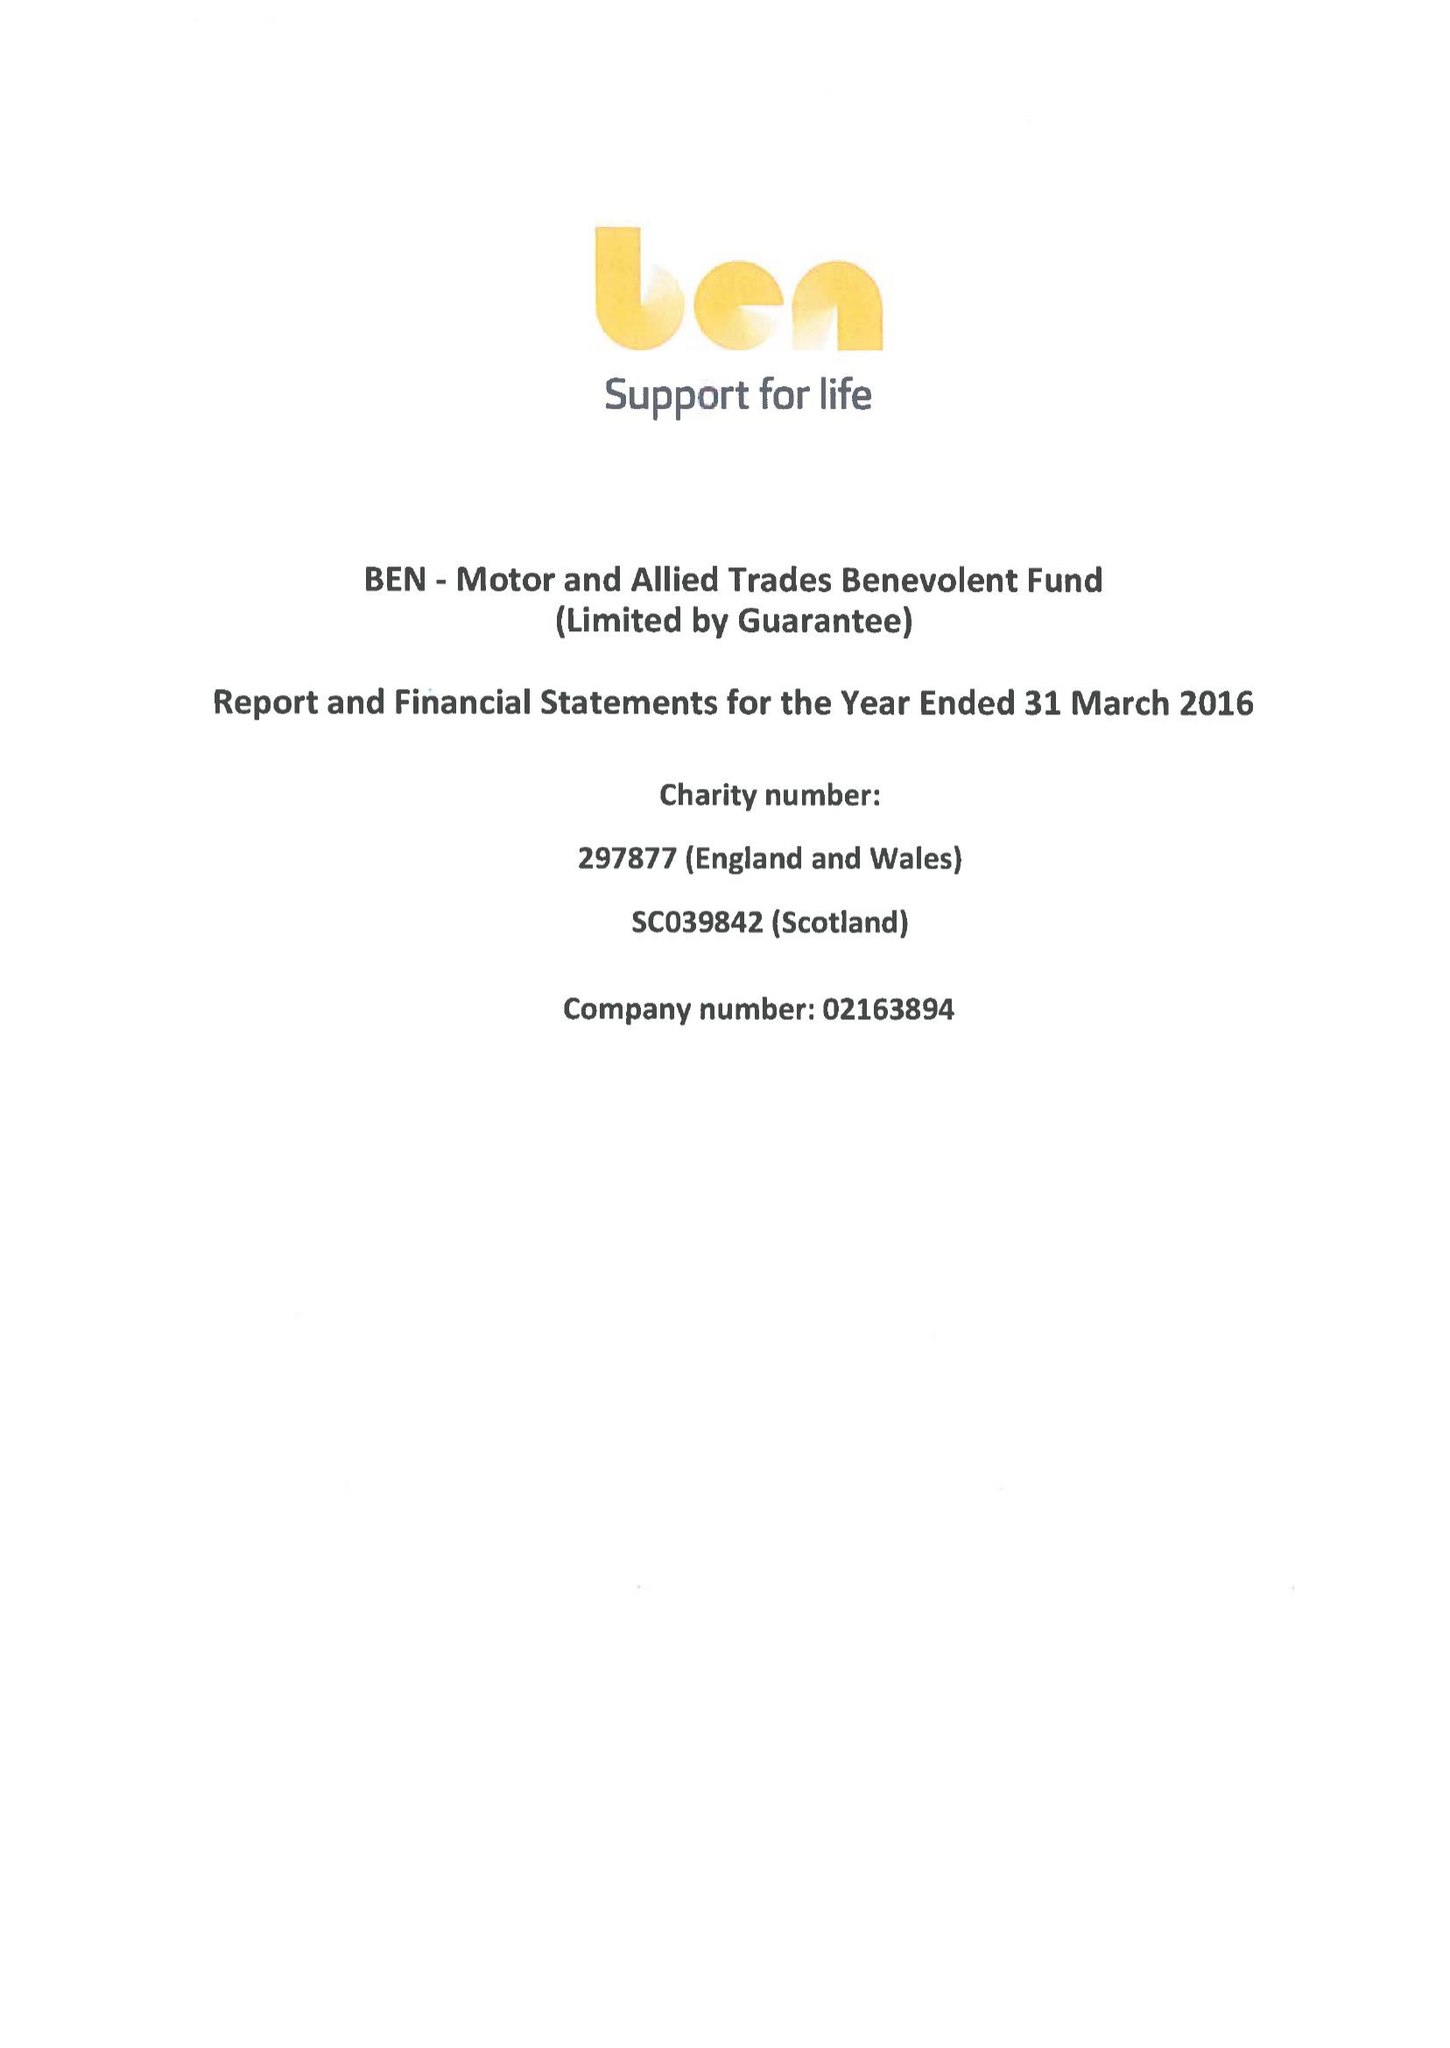What is the value for the charity_number?
Answer the question using a single word or phrase. 297877 